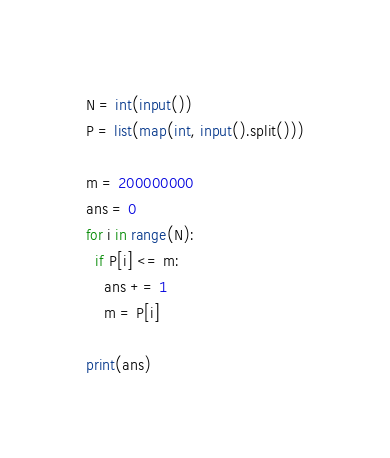<code> <loc_0><loc_0><loc_500><loc_500><_Python_>N = int(input())
P = list(map(int, input().split()))

m = 200000000
ans = 0
for i in range(N):
  if P[i] <= m:
    ans += 1
    m = P[i]

print(ans)</code> 